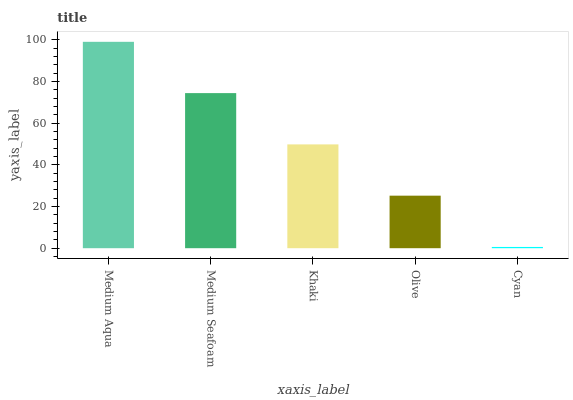Is Cyan the minimum?
Answer yes or no. Yes. Is Medium Aqua the maximum?
Answer yes or no. Yes. Is Medium Seafoam the minimum?
Answer yes or no. No. Is Medium Seafoam the maximum?
Answer yes or no. No. Is Medium Aqua greater than Medium Seafoam?
Answer yes or no. Yes. Is Medium Seafoam less than Medium Aqua?
Answer yes or no. Yes. Is Medium Seafoam greater than Medium Aqua?
Answer yes or no. No. Is Medium Aqua less than Medium Seafoam?
Answer yes or no. No. Is Khaki the high median?
Answer yes or no. Yes. Is Khaki the low median?
Answer yes or no. Yes. Is Cyan the high median?
Answer yes or no. No. Is Olive the low median?
Answer yes or no. No. 